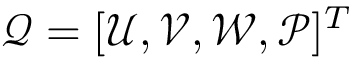<formula> <loc_0><loc_0><loc_500><loc_500>\mathcal { Q } = [ \mathcal { U } , \mathcal { V } , \mathcal { W } , \mathcal { P } ] ^ { T }</formula> 